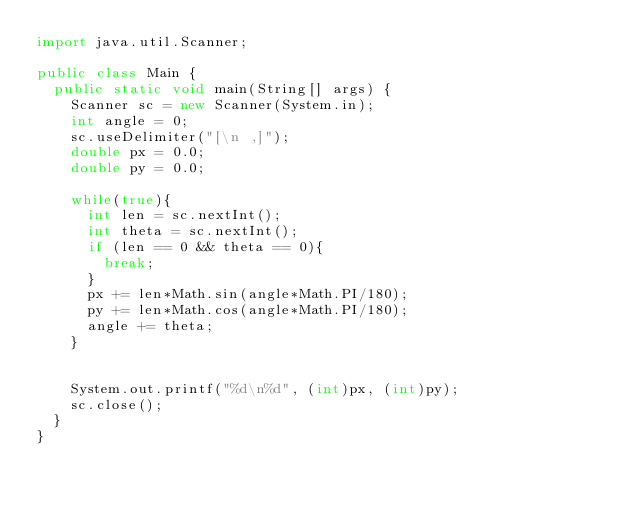Convert code to text. <code><loc_0><loc_0><loc_500><loc_500><_Java_>import java.util.Scanner;

public class Main {
	public static void main(String[] args) {
		Scanner sc = new Scanner(System.in);
		int angle = 0;
		sc.useDelimiter("[\n ,]");
		double px = 0.0;
		double py = 0.0;
		
		while(true){
			int len = sc.nextInt();
			int theta = sc.nextInt();
			if (len == 0 && theta == 0){
				break;
			}
			px += len*Math.sin(angle*Math.PI/180);
			py += len*Math.cos(angle*Math.PI/180);
			angle += theta;
		}
		

		System.out.printf("%d\n%d", (int)px, (int)py);
		sc.close();
	}
}</code> 